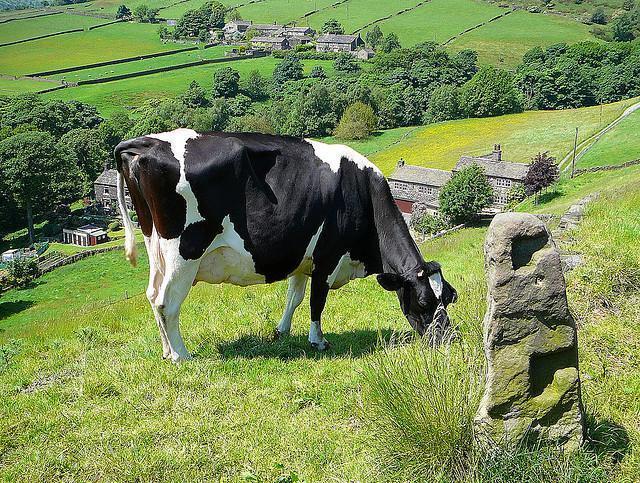How many animals are in the picture?
Give a very brief answer. 1. How many toilets are there?
Give a very brief answer. 0. 